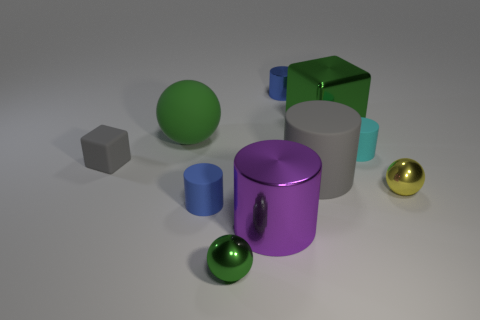Subtract all cyan cylinders. How many cylinders are left? 4 Subtract all gray cylinders. How many cylinders are left? 4 Subtract all gray cylinders. Subtract all purple cubes. How many cylinders are left? 4 Subtract all balls. How many objects are left? 7 Add 7 large metallic blocks. How many large metallic blocks are left? 8 Add 8 big cubes. How many big cubes exist? 9 Subtract 0 red cubes. How many objects are left? 10 Subtract all tiny matte cylinders. Subtract all big purple cylinders. How many objects are left? 7 